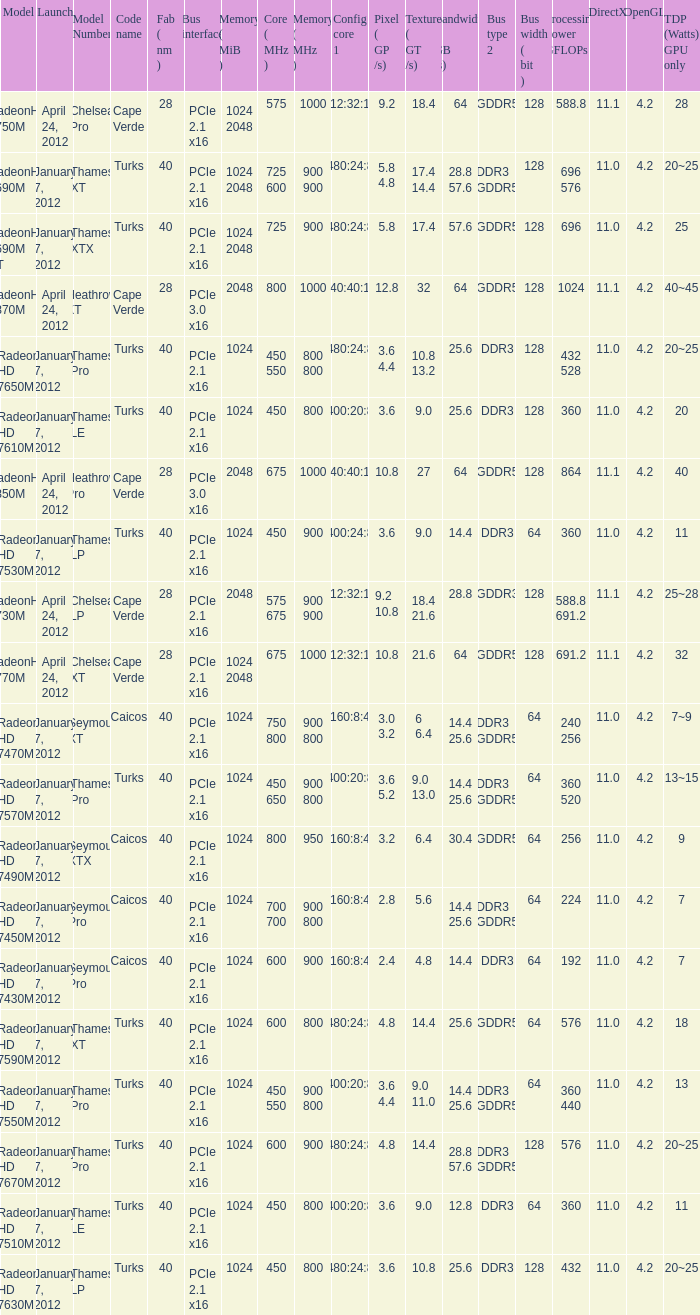What was the model's DirectX if it has a Core of 700 700 mhz? 11.0. 